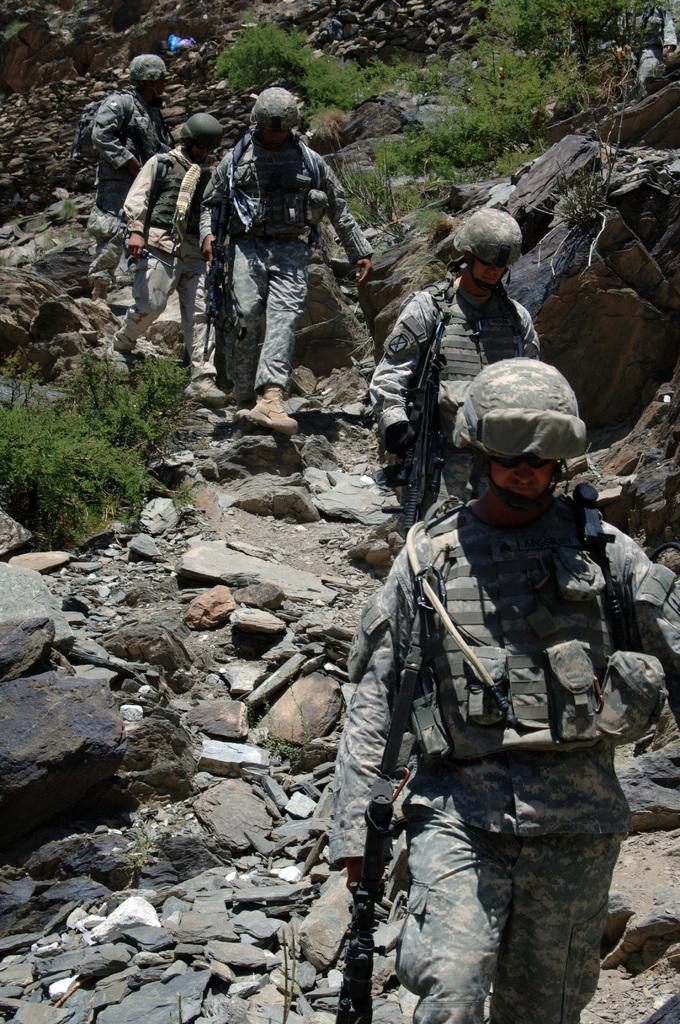What type of people can be seen in the image? There are soldiers in the image. What are the soldiers doing in the image? The soldiers are walking through a path filled with stones and rocks. What are the soldiers carrying with them? The soldiers are holding weapons. What can be seen on the right side of the image? There are plants on the right side of the image. What type of dress is the soldier wearing on the left side of the image? There is no mention of a dress in the image; the soldiers are wearing uniforms. How many cans of food can be seen in the image? There is no mention of cans of food in the image; the soldiers are holding weapons. 